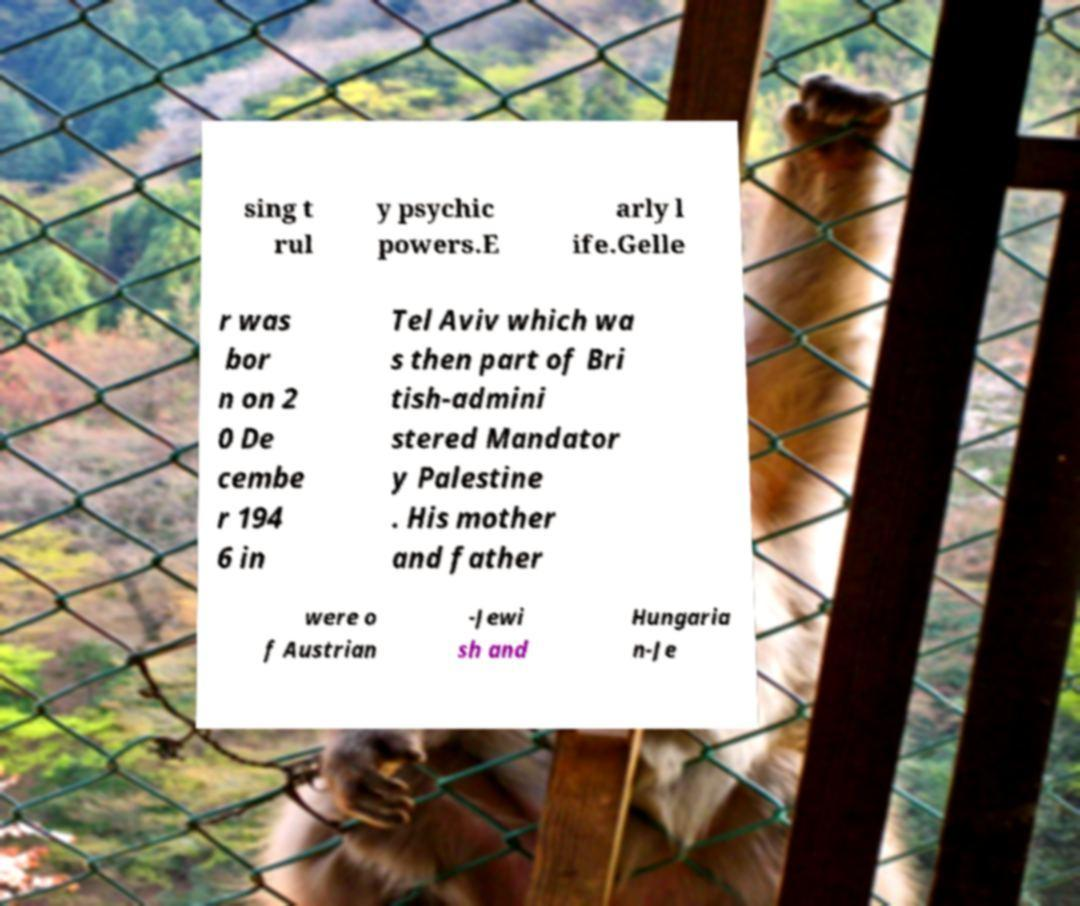Can you read and provide the text displayed in the image?This photo seems to have some interesting text. Can you extract and type it out for me? sing t rul y psychic powers.E arly l ife.Gelle r was bor n on 2 0 De cembe r 194 6 in Tel Aviv which wa s then part of Bri tish-admini stered Mandator y Palestine . His mother and father were o f Austrian -Jewi sh and Hungaria n-Je 